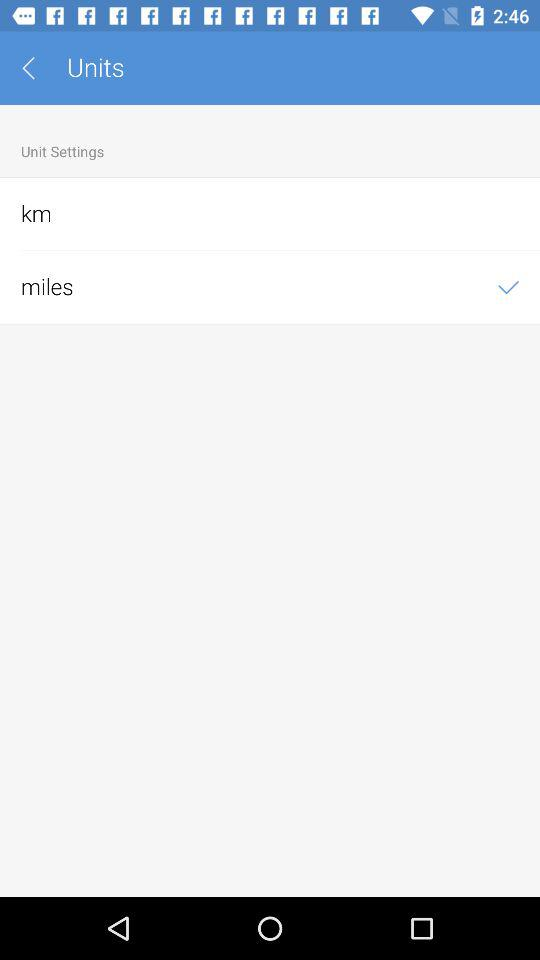What are the given units? The given units are "km" and "miles". 